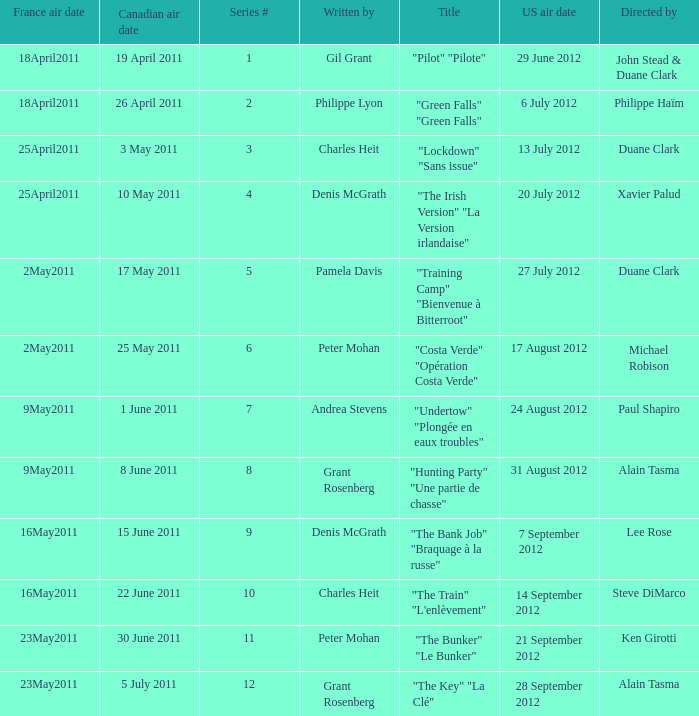What is the US air date when the director is ken girotti? 21 September 2012. 